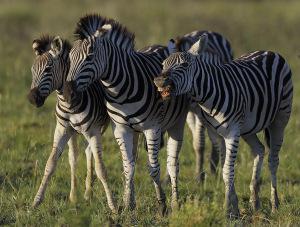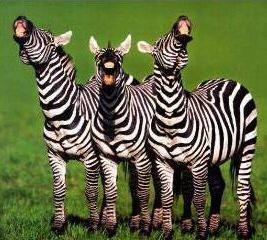The first image is the image on the left, the second image is the image on the right. Given the left and right images, does the statement "There are 6 zebras in total." hold true? Answer yes or no. Yes. The first image is the image on the left, the second image is the image on the right. Assess this claim about the two images: "Each image contains exactly three zebras, and the zebras in the right and left images face the same direction.". Correct or not? Answer yes or no. Yes. 